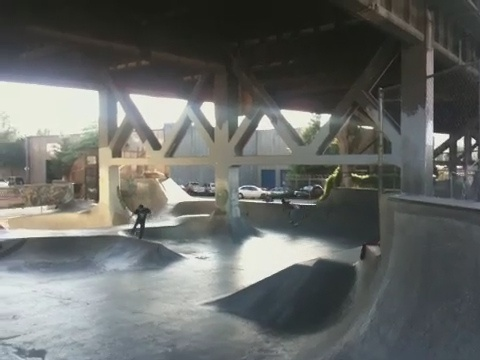Describe the objects in this image and their specific colors. I can see car in black, gray, darkgray, and lightgray tones, people in black, gray, and darkgray tones, car in black, gray, darkgray, and purple tones, car in black, gray, and darkgray tones, and car in black, gray, and darkgray tones in this image. 